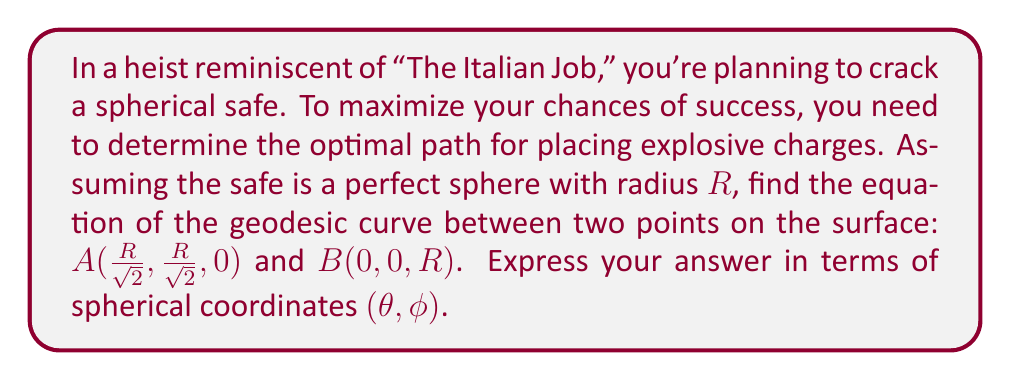Give your solution to this math problem. Let's approach this step-by-step:

1) First, recall that geodesics on a sphere are great circles, which are formed by the intersection of the sphere with a plane passing through the center of the sphere.

2) We need to find the equation of the plane containing points A, B, and the center of the sphere (0, 0, 0).

3) The normal vector to this plane can be found by the cross product of vectors OA and OB:
   $\vec{n} = \vec{OA} \times \vec{OB} = (\frac{R}{\sqrt{2}}, \frac{R}{\sqrt{2}}, 0) \times (0, 0, R) = (-\frac{R^2}{\sqrt{2}}, \frac{R^2}{\sqrt{2}}, 0)$

4) The equation of the plane is therefore:
   $-\frac{R}{\sqrt{2}}x + \frac{R}{\sqrt{2}}y = 0$
   Simplifying: $y = x$

5) In spherical coordinates, a point $(x, y, z)$ is represented as:
   $x = R \sin\phi \cos\theta$
   $y = R \sin\phi \sin\theta$
   $z = R \cos\phi$

6) Substituting these into the plane equation $y = x$:
   $R \sin\phi \sin\theta = R \sin\phi \cos\theta$

7) Simplifying:
   $\sin\theta = \cos\theta$
   $\tan\theta = 1$
   $\theta = \frac{\pi}{4}$

8) Therefore, the equation of the geodesic in spherical coordinates is:
   $\theta = \frac{\pi}{4}$, with $\phi$ varying from $\frac{\pi}{4}$ (point A) to 0 (point B).
Answer: $\theta = \frac{\pi}{4}$, $0 \leq \phi \leq \frac{\pi}{4}$ 